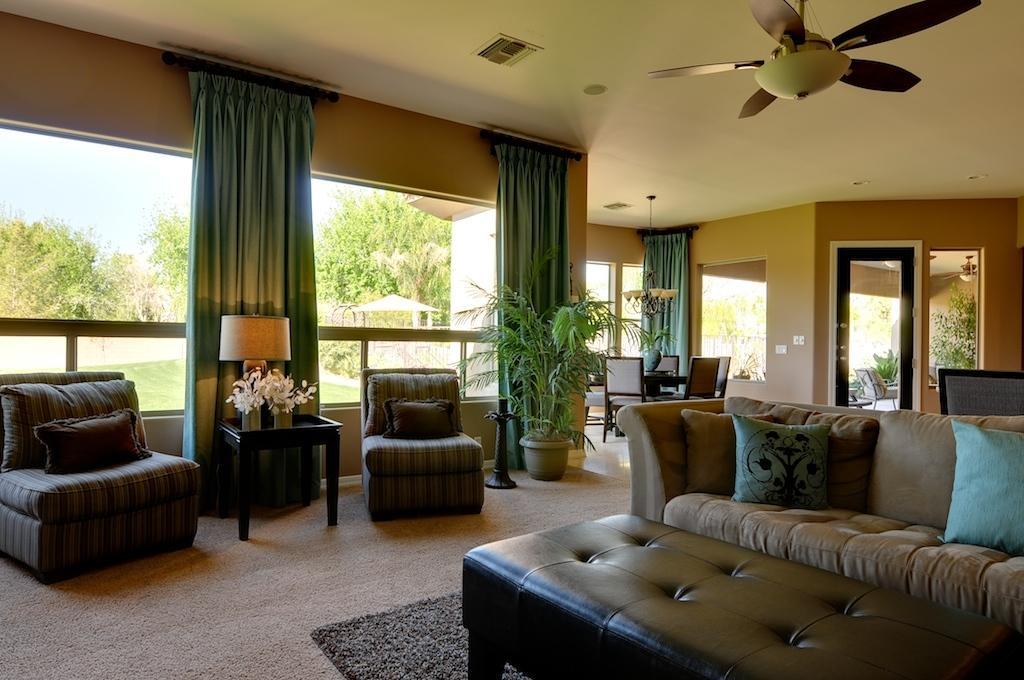Can you describe this image briefly? At the top we can see ceiling and fan. Here we can see door, windows and curtains in blue colour. Through glass door outside view is visible. We can see sky and trees.. This is floor and carpet. Here we can see sofa and chairs with cushions. on the table we can see flower vase. This is a houseplant. 